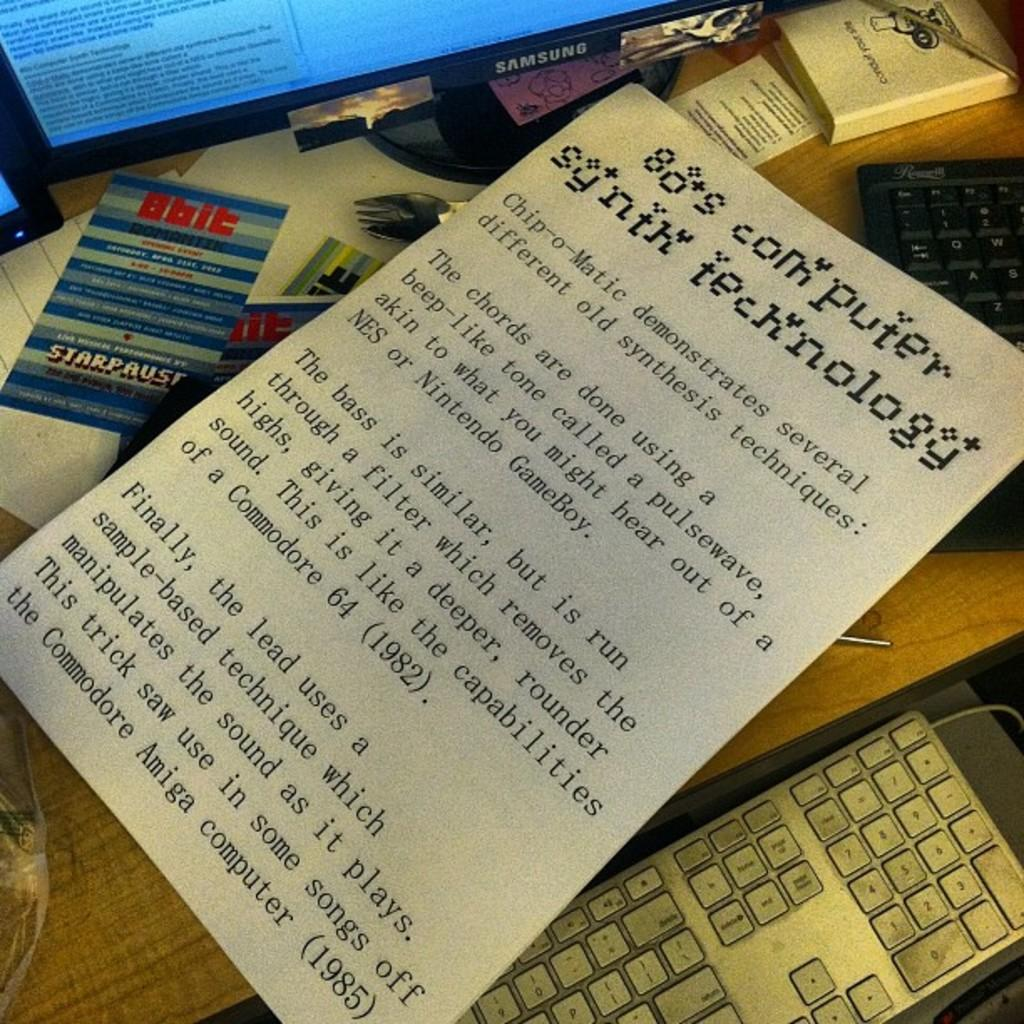Provide a one-sentence caption for the provided image. A piece of paper explaining 80s computer synth technology sits on a desk. 